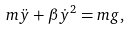<formula> <loc_0><loc_0><loc_500><loc_500>m \ddot { y } + \beta { \dot { y } } ^ { 2 } = m g ,</formula> 